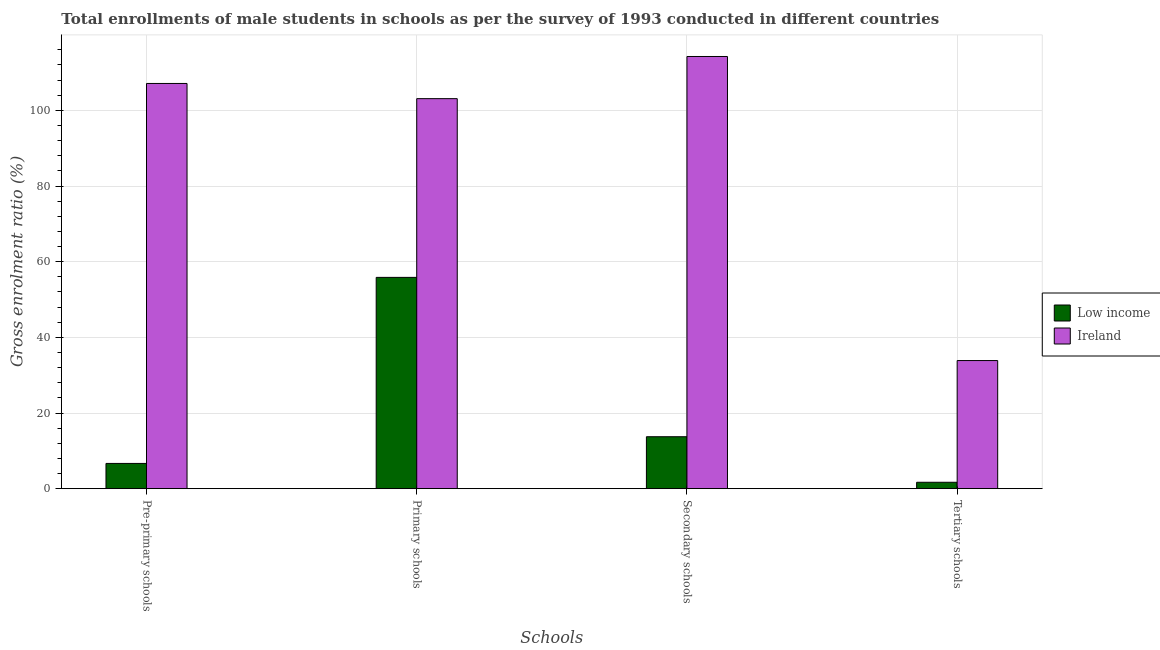Are the number of bars per tick equal to the number of legend labels?
Offer a very short reply. Yes. Are the number of bars on each tick of the X-axis equal?
Your answer should be compact. Yes. How many bars are there on the 3rd tick from the left?
Your answer should be compact. 2. How many bars are there on the 4th tick from the right?
Offer a terse response. 2. What is the label of the 4th group of bars from the left?
Keep it short and to the point. Tertiary schools. What is the gross enrolment ratio(male) in primary schools in Ireland?
Ensure brevity in your answer.  103.09. Across all countries, what is the maximum gross enrolment ratio(male) in pre-primary schools?
Offer a very short reply. 107.11. Across all countries, what is the minimum gross enrolment ratio(male) in secondary schools?
Make the answer very short. 13.73. In which country was the gross enrolment ratio(male) in primary schools maximum?
Your response must be concise. Ireland. In which country was the gross enrolment ratio(male) in tertiary schools minimum?
Provide a short and direct response. Low income. What is the total gross enrolment ratio(male) in tertiary schools in the graph?
Give a very brief answer. 35.56. What is the difference between the gross enrolment ratio(male) in pre-primary schools in Low income and that in Ireland?
Offer a very short reply. -100.43. What is the difference between the gross enrolment ratio(male) in pre-primary schools in Low income and the gross enrolment ratio(male) in secondary schools in Ireland?
Offer a terse response. -107.56. What is the average gross enrolment ratio(male) in tertiary schools per country?
Offer a very short reply. 17.78. What is the difference between the gross enrolment ratio(male) in primary schools and gross enrolment ratio(male) in pre-primary schools in Low income?
Give a very brief answer. 49.17. What is the ratio of the gross enrolment ratio(male) in secondary schools in Ireland to that in Low income?
Provide a succinct answer. 8.32. Is the gross enrolment ratio(male) in pre-primary schools in Low income less than that in Ireland?
Your answer should be very brief. Yes. What is the difference between the highest and the second highest gross enrolment ratio(male) in primary schools?
Make the answer very short. 47.24. What is the difference between the highest and the lowest gross enrolment ratio(male) in pre-primary schools?
Provide a succinct answer. 100.43. In how many countries, is the gross enrolment ratio(male) in tertiary schools greater than the average gross enrolment ratio(male) in tertiary schools taken over all countries?
Offer a very short reply. 1. Is it the case that in every country, the sum of the gross enrolment ratio(male) in secondary schools and gross enrolment ratio(male) in pre-primary schools is greater than the sum of gross enrolment ratio(male) in tertiary schools and gross enrolment ratio(male) in primary schools?
Provide a short and direct response. No. What does the 2nd bar from the left in Tertiary schools represents?
Keep it short and to the point. Ireland. What does the 1st bar from the right in Tertiary schools represents?
Provide a succinct answer. Ireland. Is it the case that in every country, the sum of the gross enrolment ratio(male) in pre-primary schools and gross enrolment ratio(male) in primary schools is greater than the gross enrolment ratio(male) in secondary schools?
Your response must be concise. Yes. What is the difference between two consecutive major ticks on the Y-axis?
Ensure brevity in your answer.  20. Does the graph contain grids?
Give a very brief answer. Yes. Where does the legend appear in the graph?
Give a very brief answer. Center right. How many legend labels are there?
Make the answer very short. 2. What is the title of the graph?
Your response must be concise. Total enrollments of male students in schools as per the survey of 1993 conducted in different countries. Does "Kosovo" appear as one of the legend labels in the graph?
Provide a succinct answer. No. What is the label or title of the X-axis?
Your answer should be very brief. Schools. What is the Gross enrolment ratio (%) of Low income in Pre-primary schools?
Your answer should be very brief. 6.67. What is the Gross enrolment ratio (%) in Ireland in Pre-primary schools?
Keep it short and to the point. 107.11. What is the Gross enrolment ratio (%) in Low income in Primary schools?
Make the answer very short. 55.85. What is the Gross enrolment ratio (%) in Ireland in Primary schools?
Make the answer very short. 103.09. What is the Gross enrolment ratio (%) in Low income in Secondary schools?
Provide a succinct answer. 13.73. What is the Gross enrolment ratio (%) in Ireland in Secondary schools?
Keep it short and to the point. 114.24. What is the Gross enrolment ratio (%) in Low income in Tertiary schools?
Make the answer very short. 1.69. What is the Gross enrolment ratio (%) of Ireland in Tertiary schools?
Offer a very short reply. 33.87. Across all Schools, what is the maximum Gross enrolment ratio (%) in Low income?
Make the answer very short. 55.85. Across all Schools, what is the maximum Gross enrolment ratio (%) of Ireland?
Ensure brevity in your answer.  114.24. Across all Schools, what is the minimum Gross enrolment ratio (%) of Low income?
Make the answer very short. 1.69. Across all Schools, what is the minimum Gross enrolment ratio (%) in Ireland?
Give a very brief answer. 33.87. What is the total Gross enrolment ratio (%) in Low income in the graph?
Provide a succinct answer. 77.94. What is the total Gross enrolment ratio (%) in Ireland in the graph?
Ensure brevity in your answer.  358.3. What is the difference between the Gross enrolment ratio (%) in Low income in Pre-primary schools and that in Primary schools?
Provide a short and direct response. -49.17. What is the difference between the Gross enrolment ratio (%) in Ireland in Pre-primary schools and that in Primary schools?
Keep it short and to the point. 4.02. What is the difference between the Gross enrolment ratio (%) of Low income in Pre-primary schools and that in Secondary schools?
Your answer should be very brief. -7.06. What is the difference between the Gross enrolment ratio (%) in Ireland in Pre-primary schools and that in Secondary schools?
Your response must be concise. -7.13. What is the difference between the Gross enrolment ratio (%) of Low income in Pre-primary schools and that in Tertiary schools?
Offer a terse response. 4.98. What is the difference between the Gross enrolment ratio (%) of Ireland in Pre-primary schools and that in Tertiary schools?
Your answer should be compact. 73.24. What is the difference between the Gross enrolment ratio (%) in Low income in Primary schools and that in Secondary schools?
Offer a terse response. 42.12. What is the difference between the Gross enrolment ratio (%) in Ireland in Primary schools and that in Secondary schools?
Provide a short and direct response. -11.14. What is the difference between the Gross enrolment ratio (%) in Low income in Primary schools and that in Tertiary schools?
Ensure brevity in your answer.  54.16. What is the difference between the Gross enrolment ratio (%) in Ireland in Primary schools and that in Tertiary schools?
Your response must be concise. 69.22. What is the difference between the Gross enrolment ratio (%) in Low income in Secondary schools and that in Tertiary schools?
Provide a succinct answer. 12.04. What is the difference between the Gross enrolment ratio (%) in Ireland in Secondary schools and that in Tertiary schools?
Your answer should be very brief. 80.37. What is the difference between the Gross enrolment ratio (%) of Low income in Pre-primary schools and the Gross enrolment ratio (%) of Ireland in Primary schools?
Provide a succinct answer. -96.42. What is the difference between the Gross enrolment ratio (%) in Low income in Pre-primary schools and the Gross enrolment ratio (%) in Ireland in Secondary schools?
Keep it short and to the point. -107.56. What is the difference between the Gross enrolment ratio (%) of Low income in Pre-primary schools and the Gross enrolment ratio (%) of Ireland in Tertiary schools?
Make the answer very short. -27.19. What is the difference between the Gross enrolment ratio (%) of Low income in Primary schools and the Gross enrolment ratio (%) of Ireland in Secondary schools?
Keep it short and to the point. -58.39. What is the difference between the Gross enrolment ratio (%) of Low income in Primary schools and the Gross enrolment ratio (%) of Ireland in Tertiary schools?
Offer a very short reply. 21.98. What is the difference between the Gross enrolment ratio (%) of Low income in Secondary schools and the Gross enrolment ratio (%) of Ireland in Tertiary schools?
Ensure brevity in your answer.  -20.14. What is the average Gross enrolment ratio (%) in Low income per Schools?
Provide a succinct answer. 19.49. What is the average Gross enrolment ratio (%) of Ireland per Schools?
Give a very brief answer. 89.57. What is the difference between the Gross enrolment ratio (%) of Low income and Gross enrolment ratio (%) of Ireland in Pre-primary schools?
Ensure brevity in your answer.  -100.43. What is the difference between the Gross enrolment ratio (%) of Low income and Gross enrolment ratio (%) of Ireland in Primary schools?
Give a very brief answer. -47.24. What is the difference between the Gross enrolment ratio (%) in Low income and Gross enrolment ratio (%) in Ireland in Secondary schools?
Keep it short and to the point. -100.51. What is the difference between the Gross enrolment ratio (%) of Low income and Gross enrolment ratio (%) of Ireland in Tertiary schools?
Your answer should be compact. -32.17. What is the ratio of the Gross enrolment ratio (%) of Low income in Pre-primary schools to that in Primary schools?
Provide a short and direct response. 0.12. What is the ratio of the Gross enrolment ratio (%) of Ireland in Pre-primary schools to that in Primary schools?
Your answer should be very brief. 1.04. What is the ratio of the Gross enrolment ratio (%) of Low income in Pre-primary schools to that in Secondary schools?
Provide a short and direct response. 0.49. What is the ratio of the Gross enrolment ratio (%) in Ireland in Pre-primary schools to that in Secondary schools?
Your answer should be compact. 0.94. What is the ratio of the Gross enrolment ratio (%) of Low income in Pre-primary schools to that in Tertiary schools?
Your response must be concise. 3.95. What is the ratio of the Gross enrolment ratio (%) of Ireland in Pre-primary schools to that in Tertiary schools?
Ensure brevity in your answer.  3.16. What is the ratio of the Gross enrolment ratio (%) in Low income in Primary schools to that in Secondary schools?
Your answer should be very brief. 4.07. What is the ratio of the Gross enrolment ratio (%) of Ireland in Primary schools to that in Secondary schools?
Your answer should be very brief. 0.9. What is the ratio of the Gross enrolment ratio (%) of Low income in Primary schools to that in Tertiary schools?
Ensure brevity in your answer.  33.04. What is the ratio of the Gross enrolment ratio (%) in Ireland in Primary schools to that in Tertiary schools?
Your response must be concise. 3.04. What is the ratio of the Gross enrolment ratio (%) in Low income in Secondary schools to that in Tertiary schools?
Provide a succinct answer. 8.12. What is the ratio of the Gross enrolment ratio (%) in Ireland in Secondary schools to that in Tertiary schools?
Provide a short and direct response. 3.37. What is the difference between the highest and the second highest Gross enrolment ratio (%) of Low income?
Ensure brevity in your answer.  42.12. What is the difference between the highest and the second highest Gross enrolment ratio (%) of Ireland?
Keep it short and to the point. 7.13. What is the difference between the highest and the lowest Gross enrolment ratio (%) in Low income?
Keep it short and to the point. 54.16. What is the difference between the highest and the lowest Gross enrolment ratio (%) of Ireland?
Offer a terse response. 80.37. 